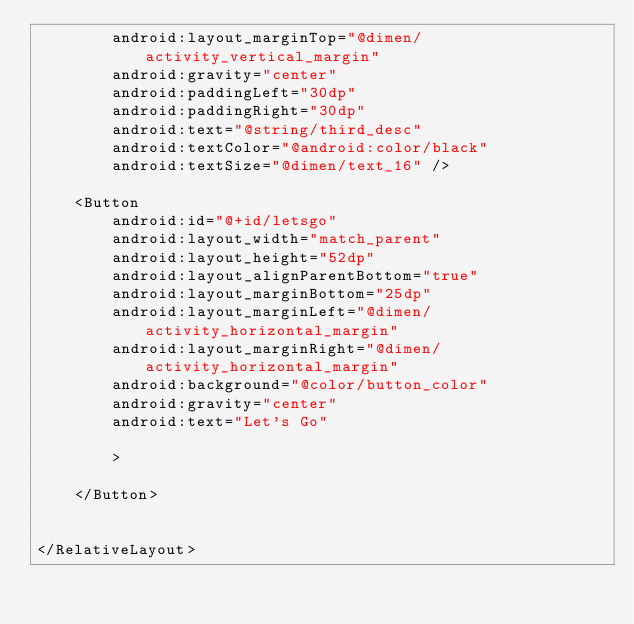Convert code to text. <code><loc_0><loc_0><loc_500><loc_500><_XML_>        android:layout_marginTop="@dimen/activity_vertical_margin"
        android:gravity="center"
        android:paddingLeft="30dp"
        android:paddingRight="30dp"
        android:text="@string/third_desc"
        android:textColor="@android:color/black"
        android:textSize="@dimen/text_16" />

    <Button
        android:id="@+id/letsgo"
        android:layout_width="match_parent"
        android:layout_height="52dp"
        android:layout_alignParentBottom="true"
        android:layout_marginBottom="25dp"
        android:layout_marginLeft="@dimen/activity_horizontal_margin"
        android:layout_marginRight="@dimen/activity_horizontal_margin"
        android:background="@color/button_color"
        android:gravity="center"
        android:text="Let's Go"

        >

    </Button>


</RelativeLayout></code> 